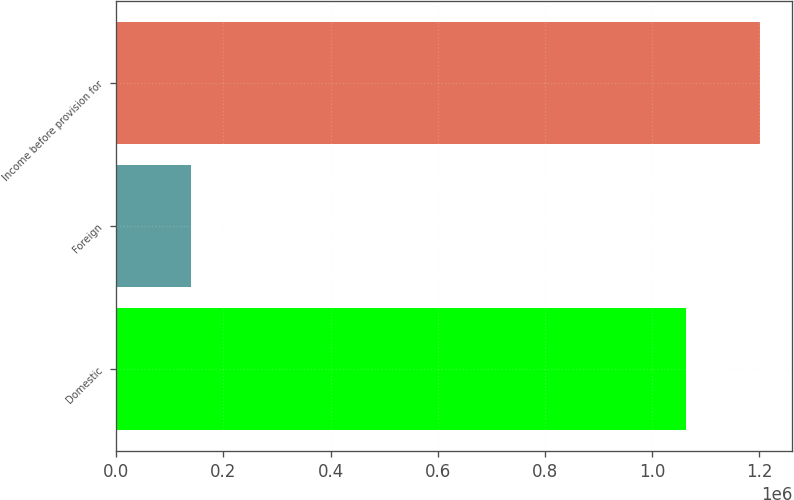Convert chart. <chart><loc_0><loc_0><loc_500><loc_500><bar_chart><fcel>Domestic<fcel>Foreign<fcel>Income before provision for<nl><fcel>1.06271e+06<fcel>138910<fcel>1.20162e+06<nl></chart> 